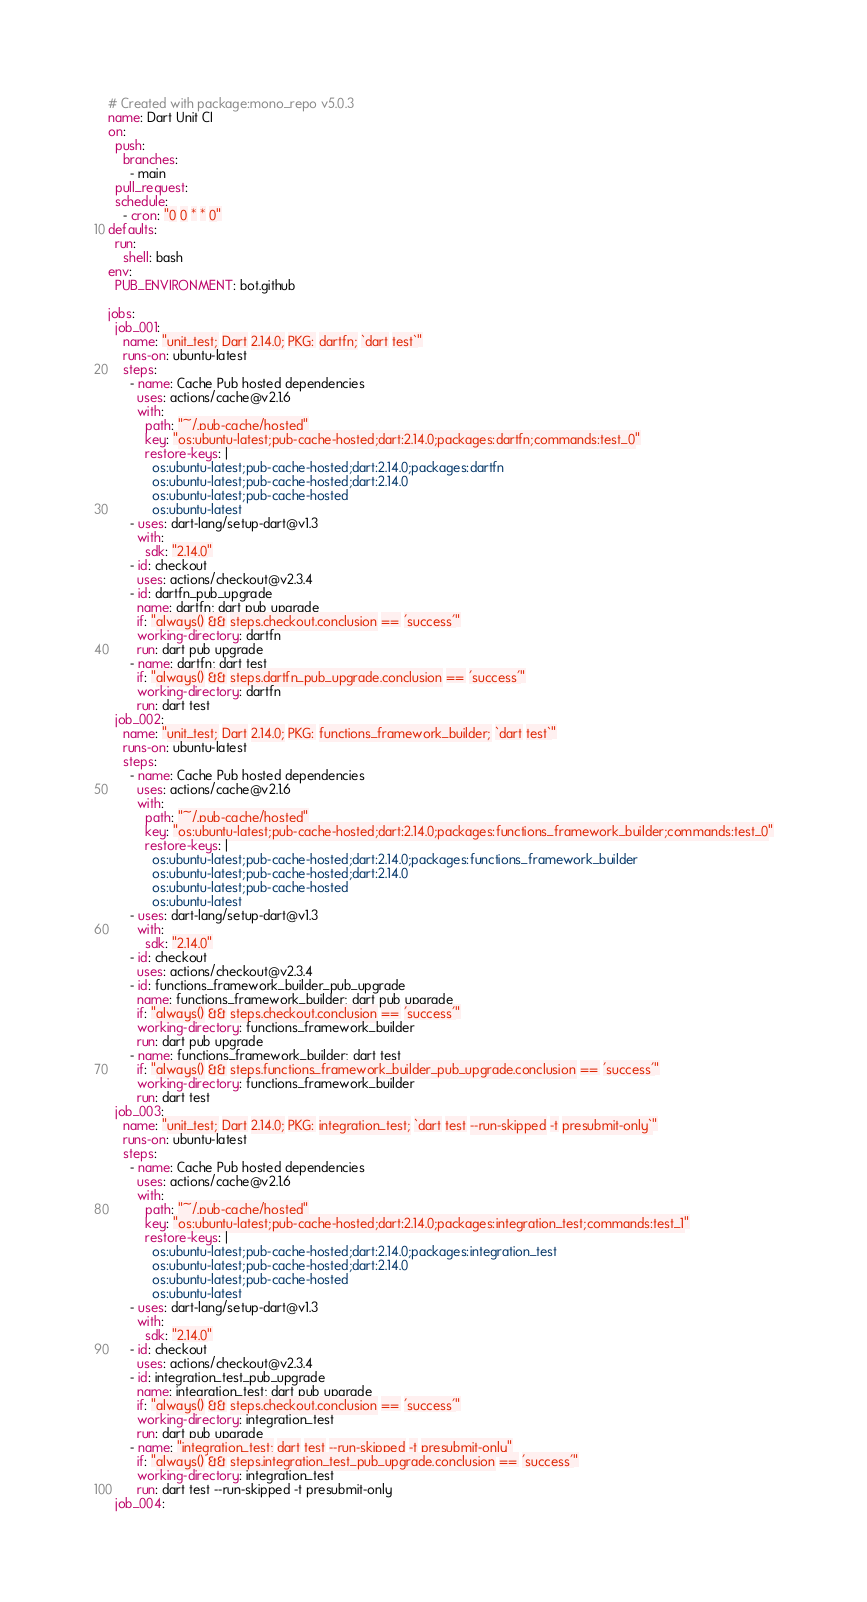<code> <loc_0><loc_0><loc_500><loc_500><_YAML_># Created with package:mono_repo v5.0.3
name: Dart Unit CI
on:
  push:
    branches:
      - main
  pull_request:
  schedule:
    - cron: "0 0 * * 0"
defaults:
  run:
    shell: bash
env:
  PUB_ENVIRONMENT: bot.github

jobs:
  job_001:
    name: "unit_test; Dart 2.14.0; PKG: dartfn; `dart test`"
    runs-on: ubuntu-latest
    steps:
      - name: Cache Pub hosted dependencies
        uses: actions/cache@v2.1.6
        with:
          path: "~/.pub-cache/hosted"
          key: "os:ubuntu-latest;pub-cache-hosted;dart:2.14.0;packages:dartfn;commands:test_0"
          restore-keys: |
            os:ubuntu-latest;pub-cache-hosted;dart:2.14.0;packages:dartfn
            os:ubuntu-latest;pub-cache-hosted;dart:2.14.0
            os:ubuntu-latest;pub-cache-hosted
            os:ubuntu-latest
      - uses: dart-lang/setup-dart@v1.3
        with:
          sdk: "2.14.0"
      - id: checkout
        uses: actions/checkout@v2.3.4
      - id: dartfn_pub_upgrade
        name: dartfn; dart pub upgrade
        if: "always() && steps.checkout.conclusion == 'success'"
        working-directory: dartfn
        run: dart pub upgrade
      - name: dartfn; dart test
        if: "always() && steps.dartfn_pub_upgrade.conclusion == 'success'"
        working-directory: dartfn
        run: dart test
  job_002:
    name: "unit_test; Dart 2.14.0; PKG: functions_framework_builder; `dart test`"
    runs-on: ubuntu-latest
    steps:
      - name: Cache Pub hosted dependencies
        uses: actions/cache@v2.1.6
        with:
          path: "~/.pub-cache/hosted"
          key: "os:ubuntu-latest;pub-cache-hosted;dart:2.14.0;packages:functions_framework_builder;commands:test_0"
          restore-keys: |
            os:ubuntu-latest;pub-cache-hosted;dart:2.14.0;packages:functions_framework_builder
            os:ubuntu-latest;pub-cache-hosted;dart:2.14.0
            os:ubuntu-latest;pub-cache-hosted
            os:ubuntu-latest
      - uses: dart-lang/setup-dart@v1.3
        with:
          sdk: "2.14.0"
      - id: checkout
        uses: actions/checkout@v2.3.4
      - id: functions_framework_builder_pub_upgrade
        name: functions_framework_builder; dart pub upgrade
        if: "always() && steps.checkout.conclusion == 'success'"
        working-directory: functions_framework_builder
        run: dart pub upgrade
      - name: functions_framework_builder; dart test
        if: "always() && steps.functions_framework_builder_pub_upgrade.conclusion == 'success'"
        working-directory: functions_framework_builder
        run: dart test
  job_003:
    name: "unit_test; Dart 2.14.0; PKG: integration_test; `dart test --run-skipped -t presubmit-only`"
    runs-on: ubuntu-latest
    steps:
      - name: Cache Pub hosted dependencies
        uses: actions/cache@v2.1.6
        with:
          path: "~/.pub-cache/hosted"
          key: "os:ubuntu-latest;pub-cache-hosted;dart:2.14.0;packages:integration_test;commands:test_1"
          restore-keys: |
            os:ubuntu-latest;pub-cache-hosted;dart:2.14.0;packages:integration_test
            os:ubuntu-latest;pub-cache-hosted;dart:2.14.0
            os:ubuntu-latest;pub-cache-hosted
            os:ubuntu-latest
      - uses: dart-lang/setup-dart@v1.3
        with:
          sdk: "2.14.0"
      - id: checkout
        uses: actions/checkout@v2.3.4
      - id: integration_test_pub_upgrade
        name: integration_test; dart pub upgrade
        if: "always() && steps.checkout.conclusion == 'success'"
        working-directory: integration_test
        run: dart pub upgrade
      - name: "integration_test; dart test --run-skipped -t presubmit-only"
        if: "always() && steps.integration_test_pub_upgrade.conclusion == 'success'"
        working-directory: integration_test
        run: dart test --run-skipped -t presubmit-only
  job_004:</code> 